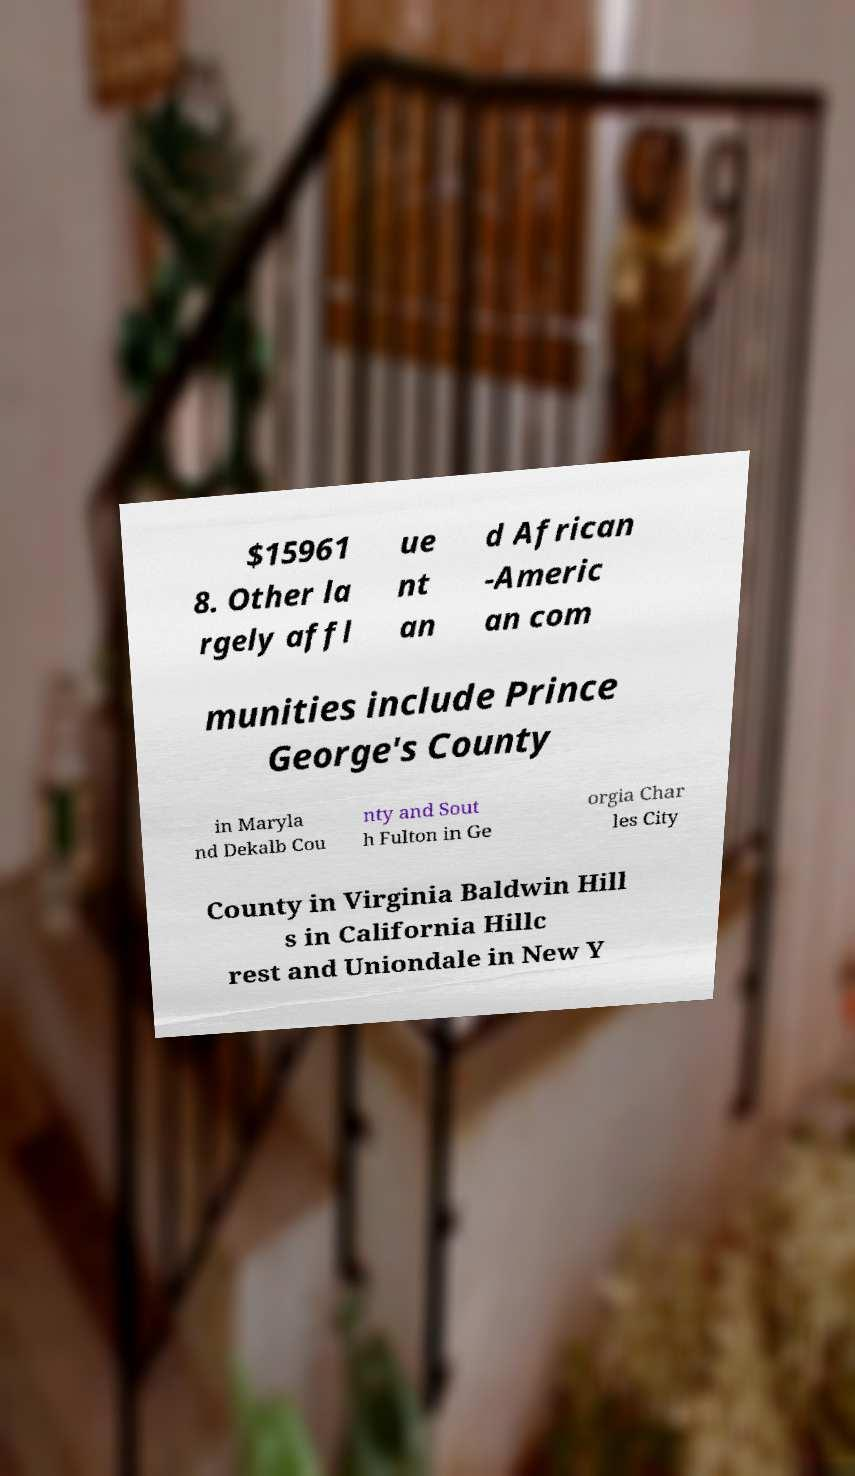What messages or text are displayed in this image? I need them in a readable, typed format. $15961 8. Other la rgely affl ue nt an d African -Americ an com munities include Prince George's County in Maryla nd Dekalb Cou nty and Sout h Fulton in Ge orgia Char les City County in Virginia Baldwin Hill s in California Hillc rest and Uniondale in New Y 